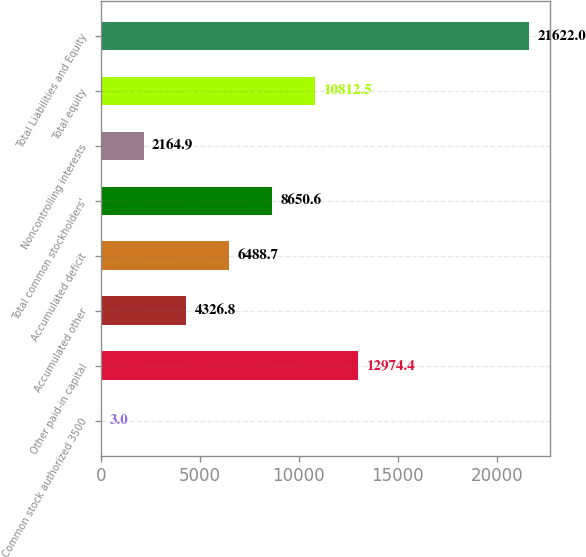Convert chart. <chart><loc_0><loc_0><loc_500><loc_500><bar_chart><fcel>Common stock authorized 3500<fcel>Other paid-in capital<fcel>Accumulated other<fcel>Accumulated deficit<fcel>Total common stockholders'<fcel>Noncontrolling interests<fcel>Total equity<fcel>Total Liabilities and Equity<nl><fcel>3<fcel>12974.4<fcel>4326.8<fcel>6488.7<fcel>8650.6<fcel>2164.9<fcel>10812.5<fcel>21622<nl></chart> 